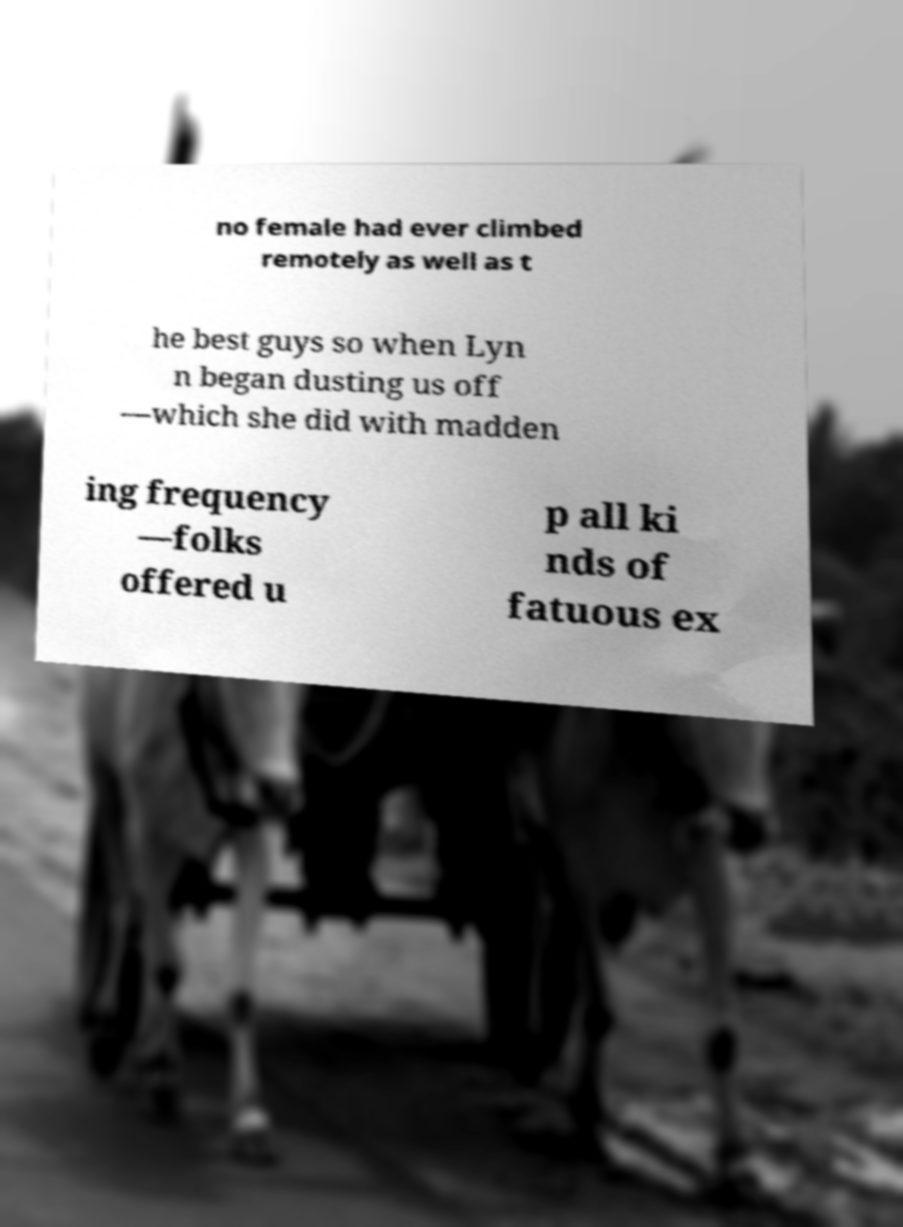Please read and relay the text visible in this image. What does it say? no female had ever climbed remotely as well as t he best guys so when Lyn n began dusting us off —which she did with madden ing frequency —folks offered u p all ki nds of fatuous ex 